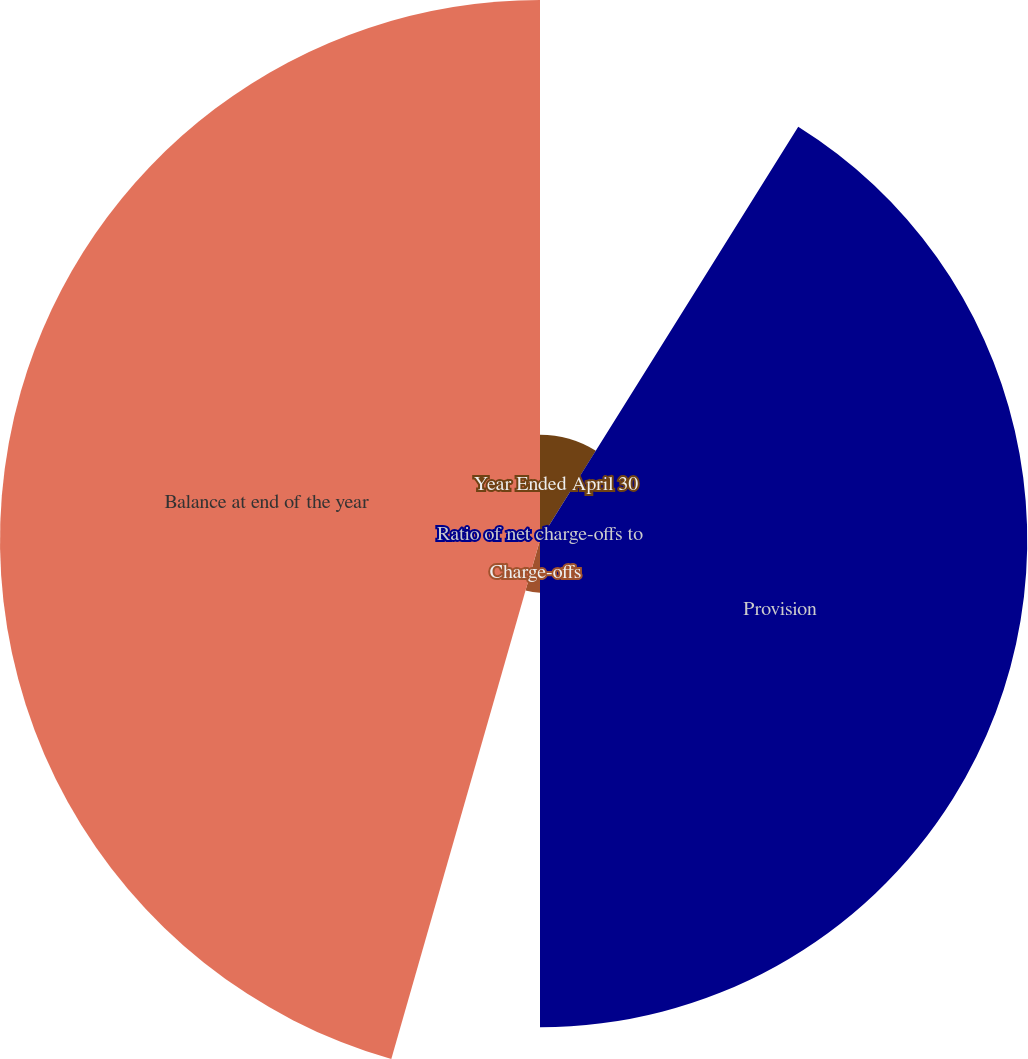Convert chart to OTSL. <chart><loc_0><loc_0><loc_500><loc_500><pie_chart><fcel>Year Ended April 30<fcel>Provision<fcel>Charge-offs<fcel>Balance at end of the year<fcel>Ratio of net charge-offs to<nl><fcel>8.89%<fcel>41.11%<fcel>4.44%<fcel>45.56%<fcel>0.0%<nl></chart> 